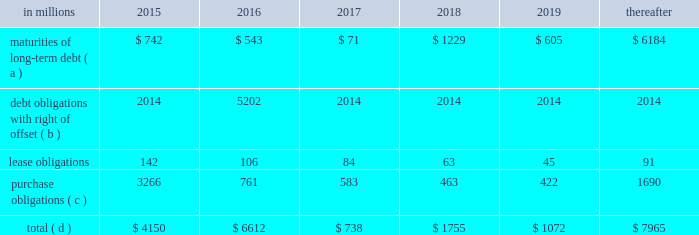On the credit rating of the company and a $ 200 million term loan with an interest rate of libor plus a margin of 175 basis points , both with maturity dates in 2017 .
The proceeds from these borrowings were used , along with available cash , to fund the acquisition of temple- inland .
During 2012 , international paper fully repaid the $ 1.2 billion term loan .
International paper utilizes interest rate swaps to change the mix of fixed and variable rate debt and manage interest expense .
At december 31 , 2012 , international paper had interest rate swaps with a total notional amount of $ 150 million and maturities in 2013 ( see note 14 derivatives and hedging activities on pages 70 through 74 of item 8 .
Financial statements and supplementary data ) .
During 2012 , existing swaps and the amortization of deferred gains on previously terminated swaps decreased the weighted average cost of debt from 6.8% ( 6.8 % ) to an effective rate of 6.6% ( 6.6 % ) .
The inclusion of the offsetting interest income from short- term investments reduced this effective rate to 6.2% ( 6.2 % ) .
Other financing activities during 2012 included the issuance of approximately 1.9 million shares of treasury stock , net of restricted stock withholding , and 1.0 million shares of common stock for various incentive plans , including stock options exercises that generated approximately $ 108 million of cash .
Payment of restricted stock withholding taxes totaled $ 35 million .
Off-balance sheet variable interest entities information concerning off-balance sheet variable interest entities is set forth in note 12 variable interest entities and preferred securities of subsidiaries on pages 67 through 69 of item 8 .
Financial statements and supplementary data for discussion .
Liquidity and capital resources outlook for 2015 capital expenditures and long-term debt international paper expects to be able to meet projected capital expenditures , service existing debt and meet working capital and dividend requirements during 2015 through current cash balances and cash from operations .
Additionally , the company has existing credit facilities totaling $ 2.0 billion of which nothing has been used .
The company was in compliance with all its debt covenants at december 31 , 2014 .
The company 2019s financial covenants require the maintenance of a minimum net worth of $ 9 billion and a total debt-to- capital ratio of less than 60% ( 60 % ) .
Net worth is defined as the sum of common stock , paid-in capital and retained earnings , less treasury stock plus any cumulative goodwill impairment charges .
The calculation also excludes accumulated other comprehensive income/ loss and nonrecourse financial liabilities of special purpose entities .
The total debt-to-capital ratio is defined as total debt divided by the sum of total debt plus net worth .
At december 31 , 2014 , international paper 2019s net worth was $ 14.0 billion , and the total-debt- to-capital ratio was 40% ( 40 % ) .
The company will continue to rely upon debt and capital markets for the majority of any necessary long-term funding not provided by operating cash flows .
Funding decisions will be guided by our capital structure planning objectives .
The primary goals of the company 2019s capital structure planning are to maximize financial flexibility and preserve liquidity while reducing interest expense .
The majority of international paper 2019s debt is accessed through global public capital markets where we have a wide base of investors .
Maintaining an investment grade credit rating is an important element of international paper 2019s financing strategy .
At december 31 , 2014 , the company held long-term credit ratings of bbb ( stable outlook ) and baa2 ( stable outlook ) by s&p and moody 2019s , respectively .
Contractual obligations for future payments under existing debt and lease commitments and purchase obligations at december 31 , 2014 , were as follows: .
( a ) total debt includes scheduled principal payments only .
( b ) represents debt obligations borrowed from non-consolidated variable interest entities for which international paper has , and intends to effect , a legal right to offset these obligations with investments held in the entities .
Accordingly , in its consolidated balance sheet at december 31 , 2014 , international paper has offset approximately $ 5.2 billion of interests in the entities against this $ 5.3 billion of debt obligations held by the entities ( see note 12 variable interest entities and preferred securities of subsidiaries on pages 67 through 69 in item 8 .
Financial statements and supplementary data ) .
( c ) includes $ 2.3 billion relating to fiber supply agreements entered into at the time of the 2006 transformation plan forestland sales and in conjunction with the 2008 acquisition of weyerhaeuser company 2019s containerboard , packaging and recycling business .
( d ) not included in the above table due to the uncertainty as to the amount and timing of the payment are unrecognized tax benefits of approximately $ 119 million .
As discussed in note 12 variable interest entities and preferred securities of subsidiaries on pages 67 through 69 in item 8 .
Financial statements and supplementary data , in connection with the 2006 international paper installment sale of forestlands , we received $ 4.8 billion of installment notes ( or timber notes ) , which we contributed to certain non- consolidated borrower entities .
The installment notes mature in august 2016 ( unless extended ) .
The deferred .
In 2014 what was the ratio of the international paper interest in other entities to debt obligation listed in the financial statements? 
Computations: (5.2 / 5.3)
Answer: 0.98113. 